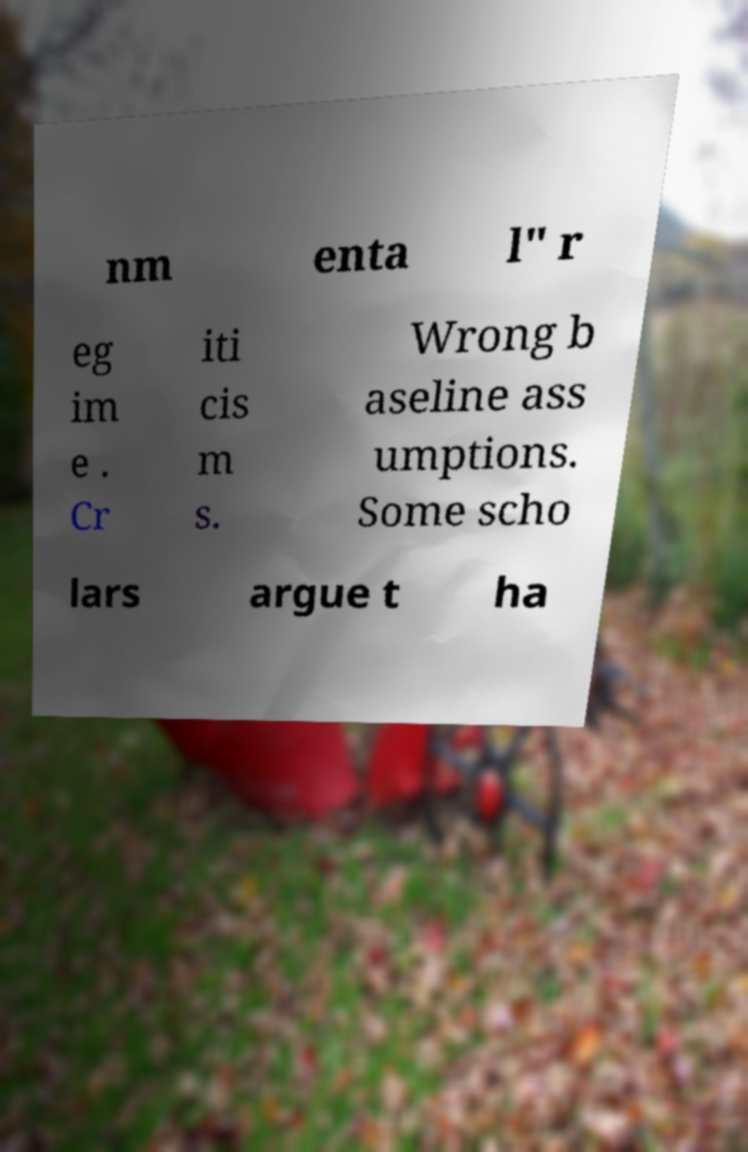Please identify and transcribe the text found in this image. nm enta l" r eg im e . Cr iti cis m s. Wrong b aseline ass umptions. Some scho lars argue t ha 